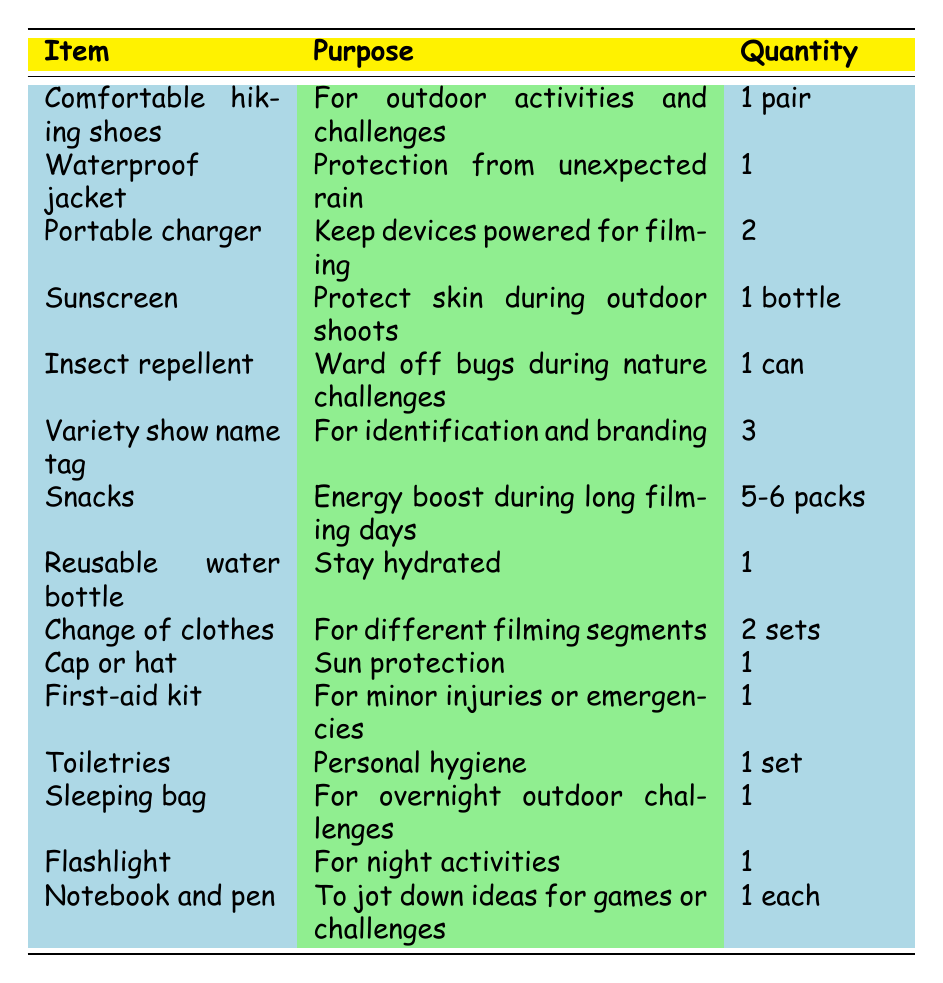What is the purpose of a portable charger? The table specifies that the purpose of a portable charger is to keep devices powered for filming.
Answer: Keep devices powered for filming How many variety show name tags are suggested to pack? According to the table, it is suggested to pack 3 variety show name tags.
Answer: 3 Is sunscreen required for the trip? Yes, the table indicates that sunscreen is needed to protect the skin during outdoor shoots.
Answer: Yes What items are needed for overnight outdoor challenges? The table lists a sleeping bag as the main item necessary for overnight outdoor challenges. There is only one item for this specific purpose.
Answer: Sleeping bag If someone packs 2 sets of clothes, how many clothes will they bring in total? Each set of clothes counts as one, so packing 2 sets means they will have 2 clothes in total, as there are no additional items counted in this context.
Answer: 2 What is the total number of food and drink-related items in the list? The table lists "Snacks" and "Reusable water bottle" as food and drink-related items. In total, there are 2 items related to food and drink.
Answer: 2 Is it true that a first-aid kit is required for the trip? Yes, the table confirms that a first-aid kit is indeed required for minor injuries or emergencies during the filming.
Answer: Yes What is the total quantity of portable chargers and first-aid kits combined? The table shows that there are 2 portable chargers and 1 first-aid kit. By adding these together, the total becomes 2 + 1 = 3.
Answer: 3 What are the two main purposes of the items in the table? The items can mainly be divided into protection (like sunscreen and jackets) and essentials (like food and first-aid kits). Protection items deal with the environment, while essentials cover hydration and energy needs.
Answer: Protection and essentials 